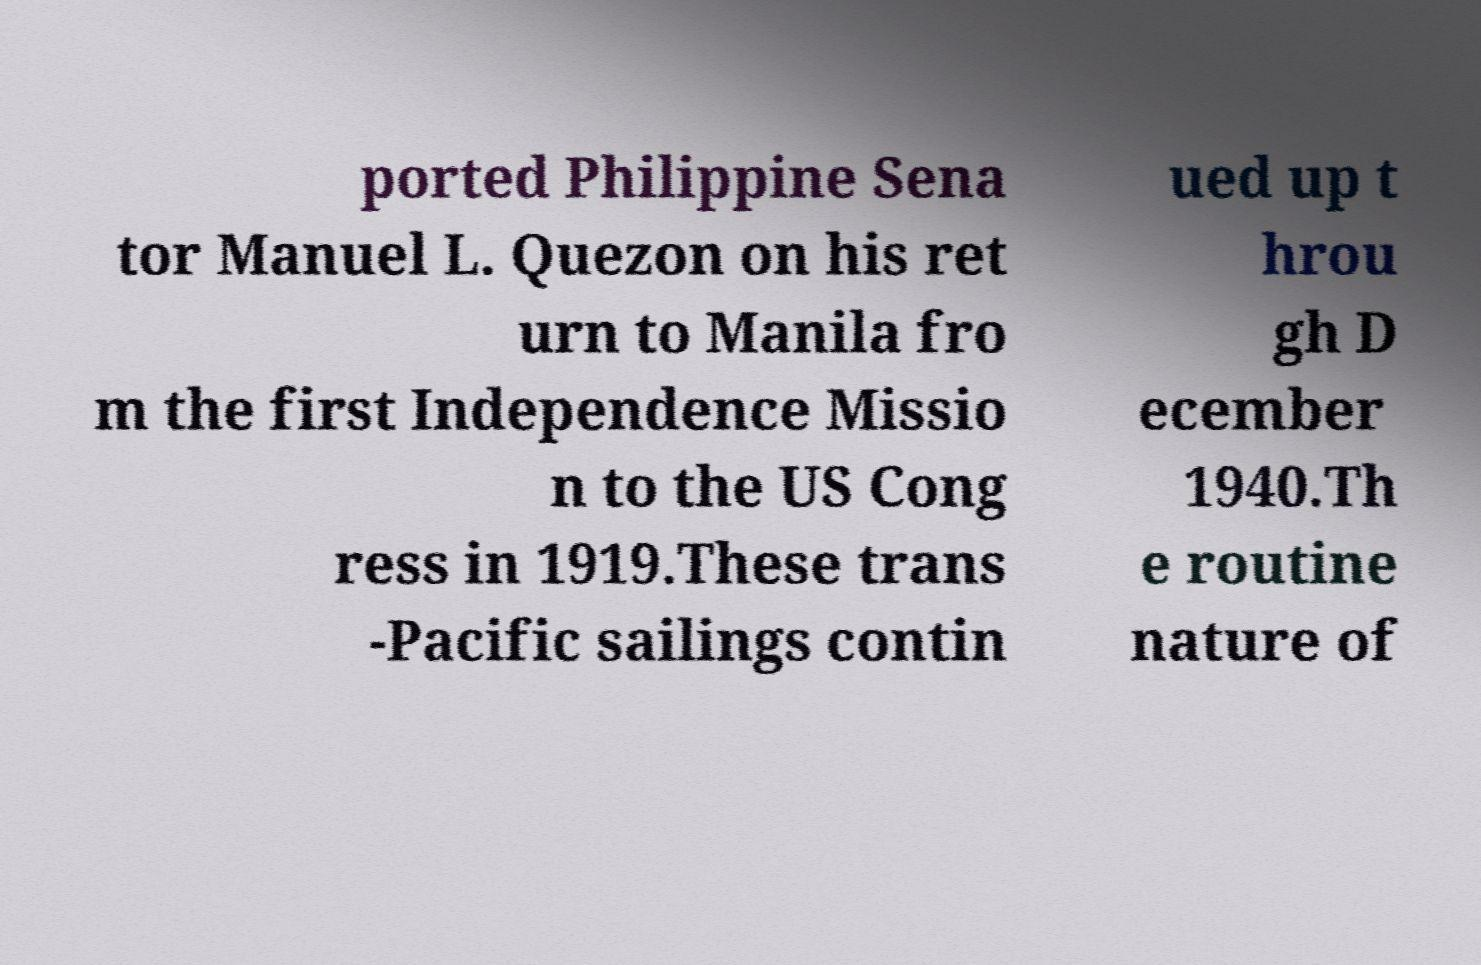Can you accurately transcribe the text from the provided image for me? ported Philippine Sena tor Manuel L. Quezon on his ret urn to Manila fro m the first Independence Missio n to the US Cong ress in 1919.These trans -Pacific sailings contin ued up t hrou gh D ecember 1940.Th e routine nature of 